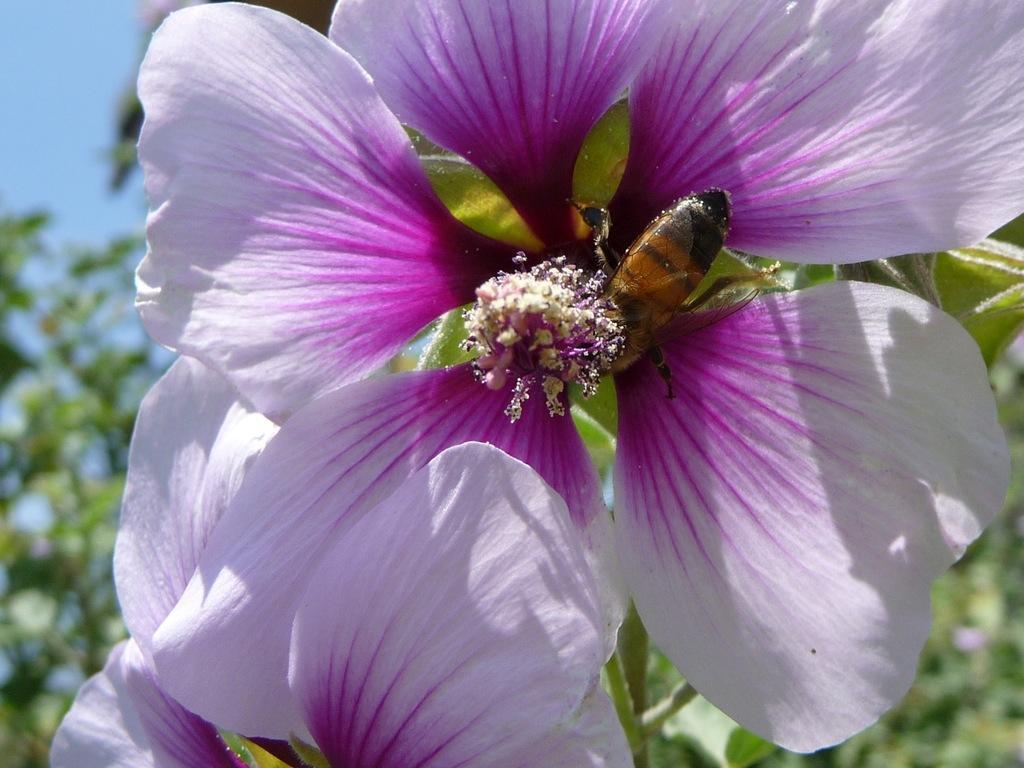Describe this image in one or two sentences. This image is taken outdoors. At the top left of the image there is the sky. In the background there are a few trees and plants with green leaves and stems. In the middle of the image there are two beautiful flowers which are purple in color and there is a honey bee on the flower. 